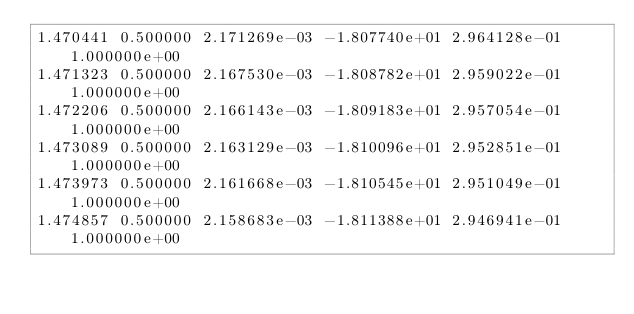Convert code to text. <code><loc_0><loc_0><loc_500><loc_500><_SQL_>1.470441 0.500000 2.171269e-03 -1.807740e+01 2.964128e-01 1.000000e+00 
1.471323 0.500000 2.167530e-03 -1.808782e+01 2.959022e-01 1.000000e+00 
1.472206 0.500000 2.166143e-03 -1.809183e+01 2.957054e-01 1.000000e+00 
1.473089 0.500000 2.163129e-03 -1.810096e+01 2.952851e-01 1.000000e+00 
1.473973 0.500000 2.161668e-03 -1.810545e+01 2.951049e-01 1.000000e+00 
1.474857 0.500000 2.158683e-03 -1.811388e+01 2.946941e-01 1.000000e+00 </code> 